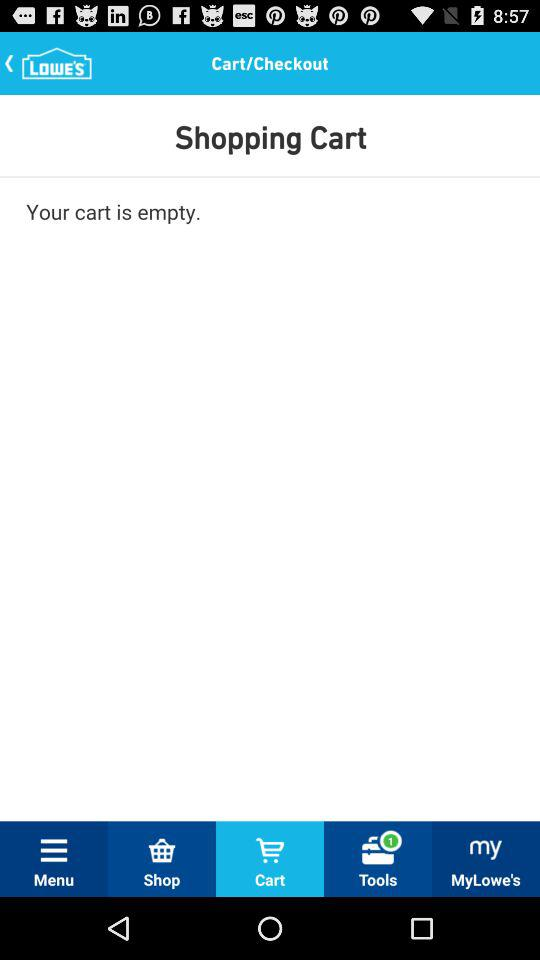How many items are in my cart?
Answer the question using a single word or phrase. 0 